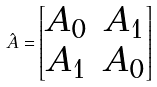<formula> <loc_0><loc_0><loc_500><loc_500>\hat { A } = \begin{bmatrix} A _ { 0 } & A _ { 1 } \\ A _ { 1 } & A _ { 0 } \end{bmatrix}</formula> 